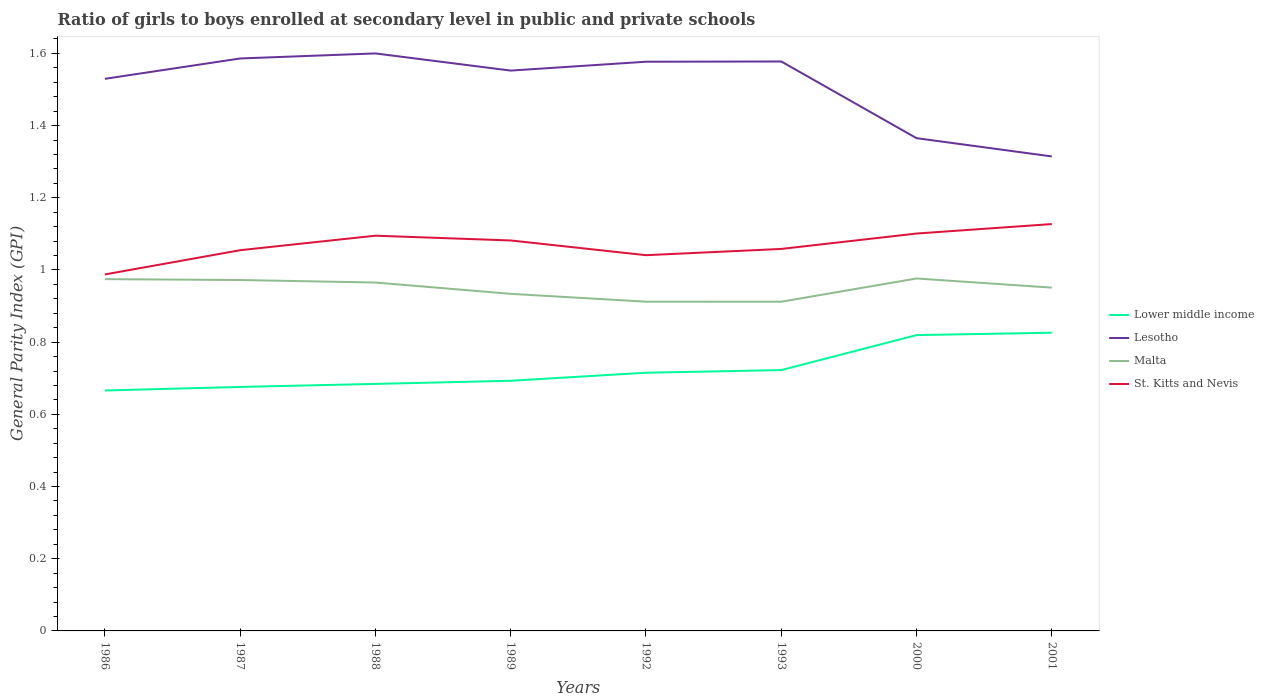Does the line corresponding to St. Kitts and Nevis intersect with the line corresponding to Lower middle income?
Give a very brief answer. No. Is the number of lines equal to the number of legend labels?
Provide a succinct answer. Yes. Across all years, what is the maximum general parity index in Lower middle income?
Your response must be concise. 0.67. In which year was the general parity index in St. Kitts and Nevis maximum?
Make the answer very short. 1986. What is the total general parity index in St. Kitts and Nevis in the graph?
Your response must be concise. -0.14. What is the difference between the highest and the second highest general parity index in Malta?
Keep it short and to the point. 0.06. Is the general parity index in Lesotho strictly greater than the general parity index in Lower middle income over the years?
Your answer should be compact. No. How many years are there in the graph?
Your answer should be very brief. 8. What is the difference between two consecutive major ticks on the Y-axis?
Offer a terse response. 0.2. Are the values on the major ticks of Y-axis written in scientific E-notation?
Offer a terse response. No. Where does the legend appear in the graph?
Offer a very short reply. Center right. What is the title of the graph?
Give a very brief answer. Ratio of girls to boys enrolled at secondary level in public and private schools. What is the label or title of the X-axis?
Your answer should be very brief. Years. What is the label or title of the Y-axis?
Give a very brief answer. General Parity Index (GPI). What is the General Parity Index (GPI) in Lower middle income in 1986?
Make the answer very short. 0.67. What is the General Parity Index (GPI) in Lesotho in 1986?
Provide a short and direct response. 1.53. What is the General Parity Index (GPI) in Malta in 1986?
Your response must be concise. 0.97. What is the General Parity Index (GPI) of St. Kitts and Nevis in 1986?
Ensure brevity in your answer.  0.99. What is the General Parity Index (GPI) of Lower middle income in 1987?
Your answer should be compact. 0.68. What is the General Parity Index (GPI) in Lesotho in 1987?
Provide a succinct answer. 1.59. What is the General Parity Index (GPI) of Malta in 1987?
Ensure brevity in your answer.  0.97. What is the General Parity Index (GPI) in St. Kitts and Nevis in 1987?
Your answer should be very brief. 1.05. What is the General Parity Index (GPI) of Lower middle income in 1988?
Your answer should be compact. 0.68. What is the General Parity Index (GPI) of Lesotho in 1988?
Keep it short and to the point. 1.6. What is the General Parity Index (GPI) of Malta in 1988?
Give a very brief answer. 0.97. What is the General Parity Index (GPI) in St. Kitts and Nevis in 1988?
Make the answer very short. 1.09. What is the General Parity Index (GPI) in Lower middle income in 1989?
Make the answer very short. 0.69. What is the General Parity Index (GPI) in Lesotho in 1989?
Ensure brevity in your answer.  1.55. What is the General Parity Index (GPI) of Malta in 1989?
Your answer should be compact. 0.93. What is the General Parity Index (GPI) in St. Kitts and Nevis in 1989?
Ensure brevity in your answer.  1.08. What is the General Parity Index (GPI) in Lower middle income in 1992?
Provide a short and direct response. 0.72. What is the General Parity Index (GPI) of Lesotho in 1992?
Give a very brief answer. 1.58. What is the General Parity Index (GPI) of Malta in 1992?
Provide a short and direct response. 0.91. What is the General Parity Index (GPI) in St. Kitts and Nevis in 1992?
Your response must be concise. 1.04. What is the General Parity Index (GPI) in Lower middle income in 1993?
Offer a terse response. 0.72. What is the General Parity Index (GPI) of Lesotho in 1993?
Make the answer very short. 1.58. What is the General Parity Index (GPI) of Malta in 1993?
Your answer should be very brief. 0.91. What is the General Parity Index (GPI) of St. Kitts and Nevis in 1993?
Ensure brevity in your answer.  1.06. What is the General Parity Index (GPI) in Lower middle income in 2000?
Your answer should be very brief. 0.82. What is the General Parity Index (GPI) in Lesotho in 2000?
Provide a short and direct response. 1.37. What is the General Parity Index (GPI) in Malta in 2000?
Your response must be concise. 0.98. What is the General Parity Index (GPI) in St. Kitts and Nevis in 2000?
Keep it short and to the point. 1.1. What is the General Parity Index (GPI) in Lower middle income in 2001?
Keep it short and to the point. 0.83. What is the General Parity Index (GPI) of Lesotho in 2001?
Provide a short and direct response. 1.31. What is the General Parity Index (GPI) of Malta in 2001?
Provide a short and direct response. 0.95. What is the General Parity Index (GPI) in St. Kitts and Nevis in 2001?
Your answer should be compact. 1.13. Across all years, what is the maximum General Parity Index (GPI) in Lower middle income?
Ensure brevity in your answer.  0.83. Across all years, what is the maximum General Parity Index (GPI) of Lesotho?
Your answer should be very brief. 1.6. Across all years, what is the maximum General Parity Index (GPI) in Malta?
Ensure brevity in your answer.  0.98. Across all years, what is the maximum General Parity Index (GPI) of St. Kitts and Nevis?
Keep it short and to the point. 1.13. Across all years, what is the minimum General Parity Index (GPI) of Lower middle income?
Your answer should be very brief. 0.67. Across all years, what is the minimum General Parity Index (GPI) of Lesotho?
Offer a very short reply. 1.31. Across all years, what is the minimum General Parity Index (GPI) of Malta?
Offer a very short reply. 0.91. Across all years, what is the minimum General Parity Index (GPI) in St. Kitts and Nevis?
Your answer should be compact. 0.99. What is the total General Parity Index (GPI) in Lower middle income in the graph?
Keep it short and to the point. 5.8. What is the total General Parity Index (GPI) in Lesotho in the graph?
Your answer should be very brief. 12.1. What is the total General Parity Index (GPI) in Malta in the graph?
Your answer should be very brief. 7.6. What is the total General Parity Index (GPI) in St. Kitts and Nevis in the graph?
Offer a terse response. 8.55. What is the difference between the General Parity Index (GPI) in Lower middle income in 1986 and that in 1987?
Make the answer very short. -0.01. What is the difference between the General Parity Index (GPI) in Lesotho in 1986 and that in 1987?
Keep it short and to the point. -0.06. What is the difference between the General Parity Index (GPI) in Malta in 1986 and that in 1987?
Provide a succinct answer. 0. What is the difference between the General Parity Index (GPI) of St. Kitts and Nevis in 1986 and that in 1987?
Ensure brevity in your answer.  -0.07. What is the difference between the General Parity Index (GPI) of Lower middle income in 1986 and that in 1988?
Your answer should be very brief. -0.02. What is the difference between the General Parity Index (GPI) of Lesotho in 1986 and that in 1988?
Keep it short and to the point. -0.07. What is the difference between the General Parity Index (GPI) of Malta in 1986 and that in 1988?
Keep it short and to the point. 0.01. What is the difference between the General Parity Index (GPI) of St. Kitts and Nevis in 1986 and that in 1988?
Provide a short and direct response. -0.11. What is the difference between the General Parity Index (GPI) in Lower middle income in 1986 and that in 1989?
Give a very brief answer. -0.03. What is the difference between the General Parity Index (GPI) of Lesotho in 1986 and that in 1989?
Your answer should be very brief. -0.02. What is the difference between the General Parity Index (GPI) in Malta in 1986 and that in 1989?
Your answer should be very brief. 0.04. What is the difference between the General Parity Index (GPI) in St. Kitts and Nevis in 1986 and that in 1989?
Provide a succinct answer. -0.09. What is the difference between the General Parity Index (GPI) in Lower middle income in 1986 and that in 1992?
Your response must be concise. -0.05. What is the difference between the General Parity Index (GPI) in Lesotho in 1986 and that in 1992?
Ensure brevity in your answer.  -0.05. What is the difference between the General Parity Index (GPI) of Malta in 1986 and that in 1992?
Your answer should be compact. 0.06. What is the difference between the General Parity Index (GPI) of St. Kitts and Nevis in 1986 and that in 1992?
Keep it short and to the point. -0.05. What is the difference between the General Parity Index (GPI) in Lower middle income in 1986 and that in 1993?
Provide a succinct answer. -0.06. What is the difference between the General Parity Index (GPI) in Lesotho in 1986 and that in 1993?
Offer a very short reply. -0.05. What is the difference between the General Parity Index (GPI) in Malta in 1986 and that in 1993?
Offer a terse response. 0.06. What is the difference between the General Parity Index (GPI) in St. Kitts and Nevis in 1986 and that in 1993?
Give a very brief answer. -0.07. What is the difference between the General Parity Index (GPI) in Lower middle income in 1986 and that in 2000?
Make the answer very short. -0.15. What is the difference between the General Parity Index (GPI) in Lesotho in 1986 and that in 2000?
Make the answer very short. 0.16. What is the difference between the General Parity Index (GPI) of Malta in 1986 and that in 2000?
Provide a succinct answer. -0. What is the difference between the General Parity Index (GPI) in St. Kitts and Nevis in 1986 and that in 2000?
Provide a short and direct response. -0.11. What is the difference between the General Parity Index (GPI) in Lower middle income in 1986 and that in 2001?
Provide a short and direct response. -0.16. What is the difference between the General Parity Index (GPI) in Lesotho in 1986 and that in 2001?
Your answer should be very brief. 0.21. What is the difference between the General Parity Index (GPI) in Malta in 1986 and that in 2001?
Your answer should be compact. 0.02. What is the difference between the General Parity Index (GPI) of St. Kitts and Nevis in 1986 and that in 2001?
Provide a short and direct response. -0.14. What is the difference between the General Parity Index (GPI) in Lower middle income in 1987 and that in 1988?
Offer a terse response. -0.01. What is the difference between the General Parity Index (GPI) of Lesotho in 1987 and that in 1988?
Your answer should be very brief. -0.01. What is the difference between the General Parity Index (GPI) of Malta in 1987 and that in 1988?
Your answer should be compact. 0.01. What is the difference between the General Parity Index (GPI) in St. Kitts and Nevis in 1987 and that in 1988?
Your answer should be very brief. -0.04. What is the difference between the General Parity Index (GPI) in Lower middle income in 1987 and that in 1989?
Keep it short and to the point. -0.02. What is the difference between the General Parity Index (GPI) in Lesotho in 1987 and that in 1989?
Give a very brief answer. 0.03. What is the difference between the General Parity Index (GPI) in Malta in 1987 and that in 1989?
Offer a very short reply. 0.04. What is the difference between the General Parity Index (GPI) of St. Kitts and Nevis in 1987 and that in 1989?
Offer a terse response. -0.03. What is the difference between the General Parity Index (GPI) of Lower middle income in 1987 and that in 1992?
Ensure brevity in your answer.  -0.04. What is the difference between the General Parity Index (GPI) in Lesotho in 1987 and that in 1992?
Offer a very short reply. 0.01. What is the difference between the General Parity Index (GPI) in Malta in 1987 and that in 1992?
Offer a very short reply. 0.06. What is the difference between the General Parity Index (GPI) in St. Kitts and Nevis in 1987 and that in 1992?
Your answer should be compact. 0.01. What is the difference between the General Parity Index (GPI) in Lower middle income in 1987 and that in 1993?
Your answer should be very brief. -0.05. What is the difference between the General Parity Index (GPI) of Lesotho in 1987 and that in 1993?
Give a very brief answer. 0.01. What is the difference between the General Parity Index (GPI) of Malta in 1987 and that in 1993?
Give a very brief answer. 0.06. What is the difference between the General Parity Index (GPI) of St. Kitts and Nevis in 1987 and that in 1993?
Give a very brief answer. -0. What is the difference between the General Parity Index (GPI) of Lower middle income in 1987 and that in 2000?
Keep it short and to the point. -0.14. What is the difference between the General Parity Index (GPI) in Lesotho in 1987 and that in 2000?
Make the answer very short. 0.22. What is the difference between the General Parity Index (GPI) of Malta in 1987 and that in 2000?
Your answer should be compact. -0. What is the difference between the General Parity Index (GPI) of St. Kitts and Nevis in 1987 and that in 2000?
Provide a succinct answer. -0.05. What is the difference between the General Parity Index (GPI) in Lower middle income in 1987 and that in 2001?
Make the answer very short. -0.15. What is the difference between the General Parity Index (GPI) of Lesotho in 1987 and that in 2001?
Provide a short and direct response. 0.27. What is the difference between the General Parity Index (GPI) in Malta in 1987 and that in 2001?
Offer a terse response. 0.02. What is the difference between the General Parity Index (GPI) in St. Kitts and Nevis in 1987 and that in 2001?
Ensure brevity in your answer.  -0.07. What is the difference between the General Parity Index (GPI) of Lower middle income in 1988 and that in 1989?
Ensure brevity in your answer.  -0.01. What is the difference between the General Parity Index (GPI) in Lesotho in 1988 and that in 1989?
Ensure brevity in your answer.  0.05. What is the difference between the General Parity Index (GPI) of Malta in 1988 and that in 1989?
Keep it short and to the point. 0.03. What is the difference between the General Parity Index (GPI) in St. Kitts and Nevis in 1988 and that in 1989?
Offer a terse response. 0.01. What is the difference between the General Parity Index (GPI) of Lower middle income in 1988 and that in 1992?
Ensure brevity in your answer.  -0.03. What is the difference between the General Parity Index (GPI) in Lesotho in 1988 and that in 1992?
Give a very brief answer. 0.02. What is the difference between the General Parity Index (GPI) of Malta in 1988 and that in 1992?
Keep it short and to the point. 0.05. What is the difference between the General Parity Index (GPI) of St. Kitts and Nevis in 1988 and that in 1992?
Your answer should be compact. 0.05. What is the difference between the General Parity Index (GPI) in Lower middle income in 1988 and that in 1993?
Your answer should be very brief. -0.04. What is the difference between the General Parity Index (GPI) in Lesotho in 1988 and that in 1993?
Make the answer very short. 0.02. What is the difference between the General Parity Index (GPI) in Malta in 1988 and that in 1993?
Offer a terse response. 0.05. What is the difference between the General Parity Index (GPI) in St. Kitts and Nevis in 1988 and that in 1993?
Your answer should be very brief. 0.04. What is the difference between the General Parity Index (GPI) in Lower middle income in 1988 and that in 2000?
Offer a terse response. -0.14. What is the difference between the General Parity Index (GPI) in Lesotho in 1988 and that in 2000?
Keep it short and to the point. 0.23. What is the difference between the General Parity Index (GPI) of Malta in 1988 and that in 2000?
Provide a succinct answer. -0.01. What is the difference between the General Parity Index (GPI) in St. Kitts and Nevis in 1988 and that in 2000?
Your answer should be very brief. -0.01. What is the difference between the General Parity Index (GPI) in Lower middle income in 1988 and that in 2001?
Ensure brevity in your answer.  -0.14. What is the difference between the General Parity Index (GPI) in Lesotho in 1988 and that in 2001?
Provide a short and direct response. 0.29. What is the difference between the General Parity Index (GPI) of Malta in 1988 and that in 2001?
Ensure brevity in your answer.  0.01. What is the difference between the General Parity Index (GPI) of St. Kitts and Nevis in 1988 and that in 2001?
Make the answer very short. -0.03. What is the difference between the General Parity Index (GPI) of Lower middle income in 1989 and that in 1992?
Your answer should be very brief. -0.02. What is the difference between the General Parity Index (GPI) in Lesotho in 1989 and that in 1992?
Provide a succinct answer. -0.02. What is the difference between the General Parity Index (GPI) in Malta in 1989 and that in 1992?
Ensure brevity in your answer.  0.02. What is the difference between the General Parity Index (GPI) in St. Kitts and Nevis in 1989 and that in 1992?
Offer a very short reply. 0.04. What is the difference between the General Parity Index (GPI) of Lower middle income in 1989 and that in 1993?
Ensure brevity in your answer.  -0.03. What is the difference between the General Parity Index (GPI) of Lesotho in 1989 and that in 1993?
Give a very brief answer. -0.03. What is the difference between the General Parity Index (GPI) in Malta in 1989 and that in 1993?
Make the answer very short. 0.02. What is the difference between the General Parity Index (GPI) of St. Kitts and Nevis in 1989 and that in 1993?
Make the answer very short. 0.02. What is the difference between the General Parity Index (GPI) in Lower middle income in 1989 and that in 2000?
Offer a very short reply. -0.13. What is the difference between the General Parity Index (GPI) of Lesotho in 1989 and that in 2000?
Give a very brief answer. 0.19. What is the difference between the General Parity Index (GPI) of Malta in 1989 and that in 2000?
Ensure brevity in your answer.  -0.04. What is the difference between the General Parity Index (GPI) in St. Kitts and Nevis in 1989 and that in 2000?
Your answer should be very brief. -0.02. What is the difference between the General Parity Index (GPI) in Lower middle income in 1989 and that in 2001?
Your answer should be very brief. -0.13. What is the difference between the General Parity Index (GPI) of Lesotho in 1989 and that in 2001?
Give a very brief answer. 0.24. What is the difference between the General Parity Index (GPI) in Malta in 1989 and that in 2001?
Make the answer very short. -0.02. What is the difference between the General Parity Index (GPI) in St. Kitts and Nevis in 1989 and that in 2001?
Keep it short and to the point. -0.05. What is the difference between the General Parity Index (GPI) of Lower middle income in 1992 and that in 1993?
Your response must be concise. -0.01. What is the difference between the General Parity Index (GPI) of Lesotho in 1992 and that in 1993?
Provide a short and direct response. -0. What is the difference between the General Parity Index (GPI) of St. Kitts and Nevis in 1992 and that in 1993?
Provide a succinct answer. -0.02. What is the difference between the General Parity Index (GPI) in Lower middle income in 1992 and that in 2000?
Your answer should be compact. -0.1. What is the difference between the General Parity Index (GPI) of Lesotho in 1992 and that in 2000?
Keep it short and to the point. 0.21. What is the difference between the General Parity Index (GPI) in Malta in 1992 and that in 2000?
Provide a short and direct response. -0.06. What is the difference between the General Parity Index (GPI) of St. Kitts and Nevis in 1992 and that in 2000?
Offer a very short reply. -0.06. What is the difference between the General Parity Index (GPI) in Lower middle income in 1992 and that in 2001?
Provide a short and direct response. -0.11. What is the difference between the General Parity Index (GPI) in Lesotho in 1992 and that in 2001?
Your response must be concise. 0.26. What is the difference between the General Parity Index (GPI) in Malta in 1992 and that in 2001?
Ensure brevity in your answer.  -0.04. What is the difference between the General Parity Index (GPI) of St. Kitts and Nevis in 1992 and that in 2001?
Provide a short and direct response. -0.09. What is the difference between the General Parity Index (GPI) in Lower middle income in 1993 and that in 2000?
Offer a terse response. -0.1. What is the difference between the General Parity Index (GPI) in Lesotho in 1993 and that in 2000?
Make the answer very short. 0.21. What is the difference between the General Parity Index (GPI) of Malta in 1993 and that in 2000?
Offer a very short reply. -0.06. What is the difference between the General Parity Index (GPI) in St. Kitts and Nevis in 1993 and that in 2000?
Give a very brief answer. -0.04. What is the difference between the General Parity Index (GPI) in Lower middle income in 1993 and that in 2001?
Provide a short and direct response. -0.1. What is the difference between the General Parity Index (GPI) in Lesotho in 1993 and that in 2001?
Your answer should be very brief. 0.26. What is the difference between the General Parity Index (GPI) in Malta in 1993 and that in 2001?
Give a very brief answer. -0.04. What is the difference between the General Parity Index (GPI) of St. Kitts and Nevis in 1993 and that in 2001?
Offer a very short reply. -0.07. What is the difference between the General Parity Index (GPI) of Lower middle income in 2000 and that in 2001?
Provide a short and direct response. -0.01. What is the difference between the General Parity Index (GPI) in Lesotho in 2000 and that in 2001?
Provide a succinct answer. 0.05. What is the difference between the General Parity Index (GPI) in Malta in 2000 and that in 2001?
Your answer should be compact. 0.03. What is the difference between the General Parity Index (GPI) of St. Kitts and Nevis in 2000 and that in 2001?
Make the answer very short. -0.03. What is the difference between the General Parity Index (GPI) in Lower middle income in 1986 and the General Parity Index (GPI) in Lesotho in 1987?
Make the answer very short. -0.92. What is the difference between the General Parity Index (GPI) of Lower middle income in 1986 and the General Parity Index (GPI) of Malta in 1987?
Keep it short and to the point. -0.31. What is the difference between the General Parity Index (GPI) of Lower middle income in 1986 and the General Parity Index (GPI) of St. Kitts and Nevis in 1987?
Make the answer very short. -0.39. What is the difference between the General Parity Index (GPI) in Lesotho in 1986 and the General Parity Index (GPI) in Malta in 1987?
Ensure brevity in your answer.  0.56. What is the difference between the General Parity Index (GPI) in Lesotho in 1986 and the General Parity Index (GPI) in St. Kitts and Nevis in 1987?
Offer a terse response. 0.47. What is the difference between the General Parity Index (GPI) in Malta in 1986 and the General Parity Index (GPI) in St. Kitts and Nevis in 1987?
Your answer should be compact. -0.08. What is the difference between the General Parity Index (GPI) in Lower middle income in 1986 and the General Parity Index (GPI) in Lesotho in 1988?
Offer a very short reply. -0.93. What is the difference between the General Parity Index (GPI) of Lower middle income in 1986 and the General Parity Index (GPI) of Malta in 1988?
Offer a terse response. -0.3. What is the difference between the General Parity Index (GPI) in Lower middle income in 1986 and the General Parity Index (GPI) in St. Kitts and Nevis in 1988?
Your answer should be very brief. -0.43. What is the difference between the General Parity Index (GPI) in Lesotho in 1986 and the General Parity Index (GPI) in Malta in 1988?
Offer a terse response. 0.56. What is the difference between the General Parity Index (GPI) of Lesotho in 1986 and the General Parity Index (GPI) of St. Kitts and Nevis in 1988?
Your answer should be very brief. 0.43. What is the difference between the General Parity Index (GPI) in Malta in 1986 and the General Parity Index (GPI) in St. Kitts and Nevis in 1988?
Keep it short and to the point. -0.12. What is the difference between the General Parity Index (GPI) of Lower middle income in 1986 and the General Parity Index (GPI) of Lesotho in 1989?
Provide a succinct answer. -0.89. What is the difference between the General Parity Index (GPI) of Lower middle income in 1986 and the General Parity Index (GPI) of Malta in 1989?
Provide a short and direct response. -0.27. What is the difference between the General Parity Index (GPI) of Lower middle income in 1986 and the General Parity Index (GPI) of St. Kitts and Nevis in 1989?
Give a very brief answer. -0.42. What is the difference between the General Parity Index (GPI) of Lesotho in 1986 and the General Parity Index (GPI) of Malta in 1989?
Provide a succinct answer. 0.6. What is the difference between the General Parity Index (GPI) of Lesotho in 1986 and the General Parity Index (GPI) of St. Kitts and Nevis in 1989?
Provide a succinct answer. 0.45. What is the difference between the General Parity Index (GPI) of Malta in 1986 and the General Parity Index (GPI) of St. Kitts and Nevis in 1989?
Give a very brief answer. -0.11. What is the difference between the General Parity Index (GPI) in Lower middle income in 1986 and the General Parity Index (GPI) in Lesotho in 1992?
Your answer should be compact. -0.91. What is the difference between the General Parity Index (GPI) of Lower middle income in 1986 and the General Parity Index (GPI) of Malta in 1992?
Provide a short and direct response. -0.25. What is the difference between the General Parity Index (GPI) of Lower middle income in 1986 and the General Parity Index (GPI) of St. Kitts and Nevis in 1992?
Keep it short and to the point. -0.37. What is the difference between the General Parity Index (GPI) in Lesotho in 1986 and the General Parity Index (GPI) in Malta in 1992?
Your answer should be compact. 0.62. What is the difference between the General Parity Index (GPI) of Lesotho in 1986 and the General Parity Index (GPI) of St. Kitts and Nevis in 1992?
Give a very brief answer. 0.49. What is the difference between the General Parity Index (GPI) in Malta in 1986 and the General Parity Index (GPI) in St. Kitts and Nevis in 1992?
Give a very brief answer. -0.07. What is the difference between the General Parity Index (GPI) in Lower middle income in 1986 and the General Parity Index (GPI) in Lesotho in 1993?
Your answer should be compact. -0.91. What is the difference between the General Parity Index (GPI) in Lower middle income in 1986 and the General Parity Index (GPI) in Malta in 1993?
Offer a terse response. -0.25. What is the difference between the General Parity Index (GPI) of Lower middle income in 1986 and the General Parity Index (GPI) of St. Kitts and Nevis in 1993?
Offer a terse response. -0.39. What is the difference between the General Parity Index (GPI) of Lesotho in 1986 and the General Parity Index (GPI) of Malta in 1993?
Give a very brief answer. 0.62. What is the difference between the General Parity Index (GPI) of Lesotho in 1986 and the General Parity Index (GPI) of St. Kitts and Nevis in 1993?
Your answer should be very brief. 0.47. What is the difference between the General Parity Index (GPI) of Malta in 1986 and the General Parity Index (GPI) of St. Kitts and Nevis in 1993?
Make the answer very short. -0.08. What is the difference between the General Parity Index (GPI) of Lower middle income in 1986 and the General Parity Index (GPI) of Lesotho in 2000?
Your answer should be compact. -0.7. What is the difference between the General Parity Index (GPI) of Lower middle income in 1986 and the General Parity Index (GPI) of Malta in 2000?
Give a very brief answer. -0.31. What is the difference between the General Parity Index (GPI) in Lower middle income in 1986 and the General Parity Index (GPI) in St. Kitts and Nevis in 2000?
Ensure brevity in your answer.  -0.43. What is the difference between the General Parity Index (GPI) of Lesotho in 1986 and the General Parity Index (GPI) of Malta in 2000?
Your answer should be very brief. 0.55. What is the difference between the General Parity Index (GPI) of Lesotho in 1986 and the General Parity Index (GPI) of St. Kitts and Nevis in 2000?
Keep it short and to the point. 0.43. What is the difference between the General Parity Index (GPI) in Malta in 1986 and the General Parity Index (GPI) in St. Kitts and Nevis in 2000?
Provide a short and direct response. -0.13. What is the difference between the General Parity Index (GPI) of Lower middle income in 1986 and the General Parity Index (GPI) of Lesotho in 2001?
Offer a very short reply. -0.65. What is the difference between the General Parity Index (GPI) in Lower middle income in 1986 and the General Parity Index (GPI) in Malta in 2001?
Ensure brevity in your answer.  -0.28. What is the difference between the General Parity Index (GPI) in Lower middle income in 1986 and the General Parity Index (GPI) in St. Kitts and Nevis in 2001?
Provide a short and direct response. -0.46. What is the difference between the General Parity Index (GPI) of Lesotho in 1986 and the General Parity Index (GPI) of Malta in 2001?
Your answer should be very brief. 0.58. What is the difference between the General Parity Index (GPI) in Lesotho in 1986 and the General Parity Index (GPI) in St. Kitts and Nevis in 2001?
Make the answer very short. 0.4. What is the difference between the General Parity Index (GPI) in Malta in 1986 and the General Parity Index (GPI) in St. Kitts and Nevis in 2001?
Your response must be concise. -0.15. What is the difference between the General Parity Index (GPI) in Lower middle income in 1987 and the General Parity Index (GPI) in Lesotho in 1988?
Give a very brief answer. -0.92. What is the difference between the General Parity Index (GPI) in Lower middle income in 1987 and the General Parity Index (GPI) in Malta in 1988?
Your answer should be compact. -0.29. What is the difference between the General Parity Index (GPI) of Lower middle income in 1987 and the General Parity Index (GPI) of St. Kitts and Nevis in 1988?
Ensure brevity in your answer.  -0.42. What is the difference between the General Parity Index (GPI) of Lesotho in 1987 and the General Parity Index (GPI) of Malta in 1988?
Your answer should be compact. 0.62. What is the difference between the General Parity Index (GPI) in Lesotho in 1987 and the General Parity Index (GPI) in St. Kitts and Nevis in 1988?
Make the answer very short. 0.49. What is the difference between the General Parity Index (GPI) of Malta in 1987 and the General Parity Index (GPI) of St. Kitts and Nevis in 1988?
Provide a succinct answer. -0.12. What is the difference between the General Parity Index (GPI) of Lower middle income in 1987 and the General Parity Index (GPI) of Lesotho in 1989?
Give a very brief answer. -0.88. What is the difference between the General Parity Index (GPI) in Lower middle income in 1987 and the General Parity Index (GPI) in Malta in 1989?
Your answer should be very brief. -0.26. What is the difference between the General Parity Index (GPI) of Lower middle income in 1987 and the General Parity Index (GPI) of St. Kitts and Nevis in 1989?
Ensure brevity in your answer.  -0.41. What is the difference between the General Parity Index (GPI) of Lesotho in 1987 and the General Parity Index (GPI) of Malta in 1989?
Keep it short and to the point. 0.65. What is the difference between the General Parity Index (GPI) of Lesotho in 1987 and the General Parity Index (GPI) of St. Kitts and Nevis in 1989?
Your response must be concise. 0.5. What is the difference between the General Parity Index (GPI) of Malta in 1987 and the General Parity Index (GPI) of St. Kitts and Nevis in 1989?
Make the answer very short. -0.11. What is the difference between the General Parity Index (GPI) in Lower middle income in 1987 and the General Parity Index (GPI) in Lesotho in 1992?
Ensure brevity in your answer.  -0.9. What is the difference between the General Parity Index (GPI) in Lower middle income in 1987 and the General Parity Index (GPI) in Malta in 1992?
Make the answer very short. -0.24. What is the difference between the General Parity Index (GPI) in Lower middle income in 1987 and the General Parity Index (GPI) in St. Kitts and Nevis in 1992?
Keep it short and to the point. -0.36. What is the difference between the General Parity Index (GPI) in Lesotho in 1987 and the General Parity Index (GPI) in Malta in 1992?
Make the answer very short. 0.67. What is the difference between the General Parity Index (GPI) of Lesotho in 1987 and the General Parity Index (GPI) of St. Kitts and Nevis in 1992?
Your answer should be very brief. 0.55. What is the difference between the General Parity Index (GPI) in Malta in 1987 and the General Parity Index (GPI) in St. Kitts and Nevis in 1992?
Your response must be concise. -0.07. What is the difference between the General Parity Index (GPI) in Lower middle income in 1987 and the General Parity Index (GPI) in Lesotho in 1993?
Keep it short and to the point. -0.9. What is the difference between the General Parity Index (GPI) in Lower middle income in 1987 and the General Parity Index (GPI) in Malta in 1993?
Provide a succinct answer. -0.24. What is the difference between the General Parity Index (GPI) in Lower middle income in 1987 and the General Parity Index (GPI) in St. Kitts and Nevis in 1993?
Offer a very short reply. -0.38. What is the difference between the General Parity Index (GPI) of Lesotho in 1987 and the General Parity Index (GPI) of Malta in 1993?
Keep it short and to the point. 0.67. What is the difference between the General Parity Index (GPI) in Lesotho in 1987 and the General Parity Index (GPI) in St. Kitts and Nevis in 1993?
Your answer should be very brief. 0.53. What is the difference between the General Parity Index (GPI) of Malta in 1987 and the General Parity Index (GPI) of St. Kitts and Nevis in 1993?
Your answer should be very brief. -0.09. What is the difference between the General Parity Index (GPI) in Lower middle income in 1987 and the General Parity Index (GPI) in Lesotho in 2000?
Offer a very short reply. -0.69. What is the difference between the General Parity Index (GPI) of Lower middle income in 1987 and the General Parity Index (GPI) of Malta in 2000?
Your response must be concise. -0.3. What is the difference between the General Parity Index (GPI) of Lower middle income in 1987 and the General Parity Index (GPI) of St. Kitts and Nevis in 2000?
Ensure brevity in your answer.  -0.42. What is the difference between the General Parity Index (GPI) of Lesotho in 1987 and the General Parity Index (GPI) of Malta in 2000?
Make the answer very short. 0.61. What is the difference between the General Parity Index (GPI) in Lesotho in 1987 and the General Parity Index (GPI) in St. Kitts and Nevis in 2000?
Offer a very short reply. 0.48. What is the difference between the General Parity Index (GPI) in Malta in 1987 and the General Parity Index (GPI) in St. Kitts and Nevis in 2000?
Keep it short and to the point. -0.13. What is the difference between the General Parity Index (GPI) of Lower middle income in 1987 and the General Parity Index (GPI) of Lesotho in 2001?
Your answer should be compact. -0.64. What is the difference between the General Parity Index (GPI) in Lower middle income in 1987 and the General Parity Index (GPI) in Malta in 2001?
Offer a very short reply. -0.28. What is the difference between the General Parity Index (GPI) of Lower middle income in 1987 and the General Parity Index (GPI) of St. Kitts and Nevis in 2001?
Make the answer very short. -0.45. What is the difference between the General Parity Index (GPI) in Lesotho in 1987 and the General Parity Index (GPI) in Malta in 2001?
Offer a terse response. 0.63. What is the difference between the General Parity Index (GPI) in Lesotho in 1987 and the General Parity Index (GPI) in St. Kitts and Nevis in 2001?
Provide a succinct answer. 0.46. What is the difference between the General Parity Index (GPI) of Malta in 1987 and the General Parity Index (GPI) of St. Kitts and Nevis in 2001?
Ensure brevity in your answer.  -0.15. What is the difference between the General Parity Index (GPI) of Lower middle income in 1988 and the General Parity Index (GPI) of Lesotho in 1989?
Your response must be concise. -0.87. What is the difference between the General Parity Index (GPI) of Lower middle income in 1988 and the General Parity Index (GPI) of Malta in 1989?
Offer a very short reply. -0.25. What is the difference between the General Parity Index (GPI) in Lower middle income in 1988 and the General Parity Index (GPI) in St. Kitts and Nevis in 1989?
Provide a succinct answer. -0.4. What is the difference between the General Parity Index (GPI) in Lesotho in 1988 and the General Parity Index (GPI) in Malta in 1989?
Your answer should be very brief. 0.67. What is the difference between the General Parity Index (GPI) of Lesotho in 1988 and the General Parity Index (GPI) of St. Kitts and Nevis in 1989?
Your response must be concise. 0.52. What is the difference between the General Parity Index (GPI) of Malta in 1988 and the General Parity Index (GPI) of St. Kitts and Nevis in 1989?
Your response must be concise. -0.12. What is the difference between the General Parity Index (GPI) of Lower middle income in 1988 and the General Parity Index (GPI) of Lesotho in 1992?
Your answer should be compact. -0.89. What is the difference between the General Parity Index (GPI) in Lower middle income in 1988 and the General Parity Index (GPI) in Malta in 1992?
Make the answer very short. -0.23. What is the difference between the General Parity Index (GPI) in Lower middle income in 1988 and the General Parity Index (GPI) in St. Kitts and Nevis in 1992?
Offer a very short reply. -0.36. What is the difference between the General Parity Index (GPI) in Lesotho in 1988 and the General Parity Index (GPI) in Malta in 1992?
Ensure brevity in your answer.  0.69. What is the difference between the General Parity Index (GPI) in Lesotho in 1988 and the General Parity Index (GPI) in St. Kitts and Nevis in 1992?
Offer a very short reply. 0.56. What is the difference between the General Parity Index (GPI) in Malta in 1988 and the General Parity Index (GPI) in St. Kitts and Nevis in 1992?
Your answer should be compact. -0.08. What is the difference between the General Parity Index (GPI) of Lower middle income in 1988 and the General Parity Index (GPI) of Lesotho in 1993?
Offer a terse response. -0.89. What is the difference between the General Parity Index (GPI) in Lower middle income in 1988 and the General Parity Index (GPI) in Malta in 1993?
Your response must be concise. -0.23. What is the difference between the General Parity Index (GPI) of Lower middle income in 1988 and the General Parity Index (GPI) of St. Kitts and Nevis in 1993?
Offer a terse response. -0.37. What is the difference between the General Parity Index (GPI) of Lesotho in 1988 and the General Parity Index (GPI) of Malta in 1993?
Ensure brevity in your answer.  0.69. What is the difference between the General Parity Index (GPI) in Lesotho in 1988 and the General Parity Index (GPI) in St. Kitts and Nevis in 1993?
Your answer should be compact. 0.54. What is the difference between the General Parity Index (GPI) of Malta in 1988 and the General Parity Index (GPI) of St. Kitts and Nevis in 1993?
Make the answer very short. -0.09. What is the difference between the General Parity Index (GPI) in Lower middle income in 1988 and the General Parity Index (GPI) in Lesotho in 2000?
Make the answer very short. -0.68. What is the difference between the General Parity Index (GPI) of Lower middle income in 1988 and the General Parity Index (GPI) of Malta in 2000?
Offer a terse response. -0.29. What is the difference between the General Parity Index (GPI) in Lower middle income in 1988 and the General Parity Index (GPI) in St. Kitts and Nevis in 2000?
Offer a very short reply. -0.42. What is the difference between the General Parity Index (GPI) of Lesotho in 1988 and the General Parity Index (GPI) of Malta in 2000?
Offer a terse response. 0.62. What is the difference between the General Parity Index (GPI) of Lesotho in 1988 and the General Parity Index (GPI) of St. Kitts and Nevis in 2000?
Offer a very short reply. 0.5. What is the difference between the General Parity Index (GPI) in Malta in 1988 and the General Parity Index (GPI) in St. Kitts and Nevis in 2000?
Provide a succinct answer. -0.14. What is the difference between the General Parity Index (GPI) in Lower middle income in 1988 and the General Parity Index (GPI) in Lesotho in 2001?
Your answer should be compact. -0.63. What is the difference between the General Parity Index (GPI) of Lower middle income in 1988 and the General Parity Index (GPI) of Malta in 2001?
Provide a short and direct response. -0.27. What is the difference between the General Parity Index (GPI) of Lower middle income in 1988 and the General Parity Index (GPI) of St. Kitts and Nevis in 2001?
Offer a very short reply. -0.44. What is the difference between the General Parity Index (GPI) of Lesotho in 1988 and the General Parity Index (GPI) of Malta in 2001?
Give a very brief answer. 0.65. What is the difference between the General Parity Index (GPI) in Lesotho in 1988 and the General Parity Index (GPI) in St. Kitts and Nevis in 2001?
Ensure brevity in your answer.  0.47. What is the difference between the General Parity Index (GPI) in Malta in 1988 and the General Parity Index (GPI) in St. Kitts and Nevis in 2001?
Ensure brevity in your answer.  -0.16. What is the difference between the General Parity Index (GPI) in Lower middle income in 1989 and the General Parity Index (GPI) in Lesotho in 1992?
Offer a very short reply. -0.88. What is the difference between the General Parity Index (GPI) in Lower middle income in 1989 and the General Parity Index (GPI) in Malta in 1992?
Offer a terse response. -0.22. What is the difference between the General Parity Index (GPI) in Lower middle income in 1989 and the General Parity Index (GPI) in St. Kitts and Nevis in 1992?
Offer a terse response. -0.35. What is the difference between the General Parity Index (GPI) of Lesotho in 1989 and the General Parity Index (GPI) of Malta in 1992?
Provide a succinct answer. 0.64. What is the difference between the General Parity Index (GPI) in Lesotho in 1989 and the General Parity Index (GPI) in St. Kitts and Nevis in 1992?
Your answer should be compact. 0.51. What is the difference between the General Parity Index (GPI) of Malta in 1989 and the General Parity Index (GPI) of St. Kitts and Nevis in 1992?
Offer a very short reply. -0.11. What is the difference between the General Parity Index (GPI) of Lower middle income in 1989 and the General Parity Index (GPI) of Lesotho in 1993?
Give a very brief answer. -0.88. What is the difference between the General Parity Index (GPI) in Lower middle income in 1989 and the General Parity Index (GPI) in Malta in 1993?
Make the answer very short. -0.22. What is the difference between the General Parity Index (GPI) in Lower middle income in 1989 and the General Parity Index (GPI) in St. Kitts and Nevis in 1993?
Your answer should be compact. -0.37. What is the difference between the General Parity Index (GPI) in Lesotho in 1989 and the General Parity Index (GPI) in Malta in 1993?
Your answer should be compact. 0.64. What is the difference between the General Parity Index (GPI) in Lesotho in 1989 and the General Parity Index (GPI) in St. Kitts and Nevis in 1993?
Your response must be concise. 0.49. What is the difference between the General Parity Index (GPI) of Malta in 1989 and the General Parity Index (GPI) of St. Kitts and Nevis in 1993?
Your answer should be compact. -0.12. What is the difference between the General Parity Index (GPI) of Lower middle income in 1989 and the General Parity Index (GPI) of Lesotho in 2000?
Ensure brevity in your answer.  -0.67. What is the difference between the General Parity Index (GPI) in Lower middle income in 1989 and the General Parity Index (GPI) in Malta in 2000?
Give a very brief answer. -0.28. What is the difference between the General Parity Index (GPI) of Lower middle income in 1989 and the General Parity Index (GPI) of St. Kitts and Nevis in 2000?
Provide a short and direct response. -0.41. What is the difference between the General Parity Index (GPI) in Lesotho in 1989 and the General Parity Index (GPI) in Malta in 2000?
Your answer should be compact. 0.58. What is the difference between the General Parity Index (GPI) of Lesotho in 1989 and the General Parity Index (GPI) of St. Kitts and Nevis in 2000?
Provide a succinct answer. 0.45. What is the difference between the General Parity Index (GPI) in Malta in 1989 and the General Parity Index (GPI) in St. Kitts and Nevis in 2000?
Your response must be concise. -0.17. What is the difference between the General Parity Index (GPI) of Lower middle income in 1989 and the General Parity Index (GPI) of Lesotho in 2001?
Provide a short and direct response. -0.62. What is the difference between the General Parity Index (GPI) in Lower middle income in 1989 and the General Parity Index (GPI) in Malta in 2001?
Offer a terse response. -0.26. What is the difference between the General Parity Index (GPI) in Lower middle income in 1989 and the General Parity Index (GPI) in St. Kitts and Nevis in 2001?
Ensure brevity in your answer.  -0.43. What is the difference between the General Parity Index (GPI) of Lesotho in 1989 and the General Parity Index (GPI) of Malta in 2001?
Provide a short and direct response. 0.6. What is the difference between the General Parity Index (GPI) in Lesotho in 1989 and the General Parity Index (GPI) in St. Kitts and Nevis in 2001?
Ensure brevity in your answer.  0.43. What is the difference between the General Parity Index (GPI) in Malta in 1989 and the General Parity Index (GPI) in St. Kitts and Nevis in 2001?
Offer a terse response. -0.19. What is the difference between the General Parity Index (GPI) in Lower middle income in 1992 and the General Parity Index (GPI) in Lesotho in 1993?
Your answer should be very brief. -0.86. What is the difference between the General Parity Index (GPI) in Lower middle income in 1992 and the General Parity Index (GPI) in Malta in 1993?
Your answer should be compact. -0.2. What is the difference between the General Parity Index (GPI) of Lower middle income in 1992 and the General Parity Index (GPI) of St. Kitts and Nevis in 1993?
Your answer should be very brief. -0.34. What is the difference between the General Parity Index (GPI) in Lesotho in 1992 and the General Parity Index (GPI) in Malta in 1993?
Give a very brief answer. 0.66. What is the difference between the General Parity Index (GPI) of Lesotho in 1992 and the General Parity Index (GPI) of St. Kitts and Nevis in 1993?
Make the answer very short. 0.52. What is the difference between the General Parity Index (GPI) in Malta in 1992 and the General Parity Index (GPI) in St. Kitts and Nevis in 1993?
Your response must be concise. -0.15. What is the difference between the General Parity Index (GPI) in Lower middle income in 1992 and the General Parity Index (GPI) in Lesotho in 2000?
Provide a succinct answer. -0.65. What is the difference between the General Parity Index (GPI) in Lower middle income in 1992 and the General Parity Index (GPI) in Malta in 2000?
Make the answer very short. -0.26. What is the difference between the General Parity Index (GPI) of Lower middle income in 1992 and the General Parity Index (GPI) of St. Kitts and Nevis in 2000?
Your answer should be very brief. -0.39. What is the difference between the General Parity Index (GPI) of Lesotho in 1992 and the General Parity Index (GPI) of Malta in 2000?
Give a very brief answer. 0.6. What is the difference between the General Parity Index (GPI) in Lesotho in 1992 and the General Parity Index (GPI) in St. Kitts and Nevis in 2000?
Your answer should be compact. 0.48. What is the difference between the General Parity Index (GPI) of Malta in 1992 and the General Parity Index (GPI) of St. Kitts and Nevis in 2000?
Your response must be concise. -0.19. What is the difference between the General Parity Index (GPI) of Lower middle income in 1992 and the General Parity Index (GPI) of Lesotho in 2001?
Offer a terse response. -0.6. What is the difference between the General Parity Index (GPI) of Lower middle income in 1992 and the General Parity Index (GPI) of Malta in 2001?
Keep it short and to the point. -0.24. What is the difference between the General Parity Index (GPI) in Lower middle income in 1992 and the General Parity Index (GPI) in St. Kitts and Nevis in 2001?
Provide a short and direct response. -0.41. What is the difference between the General Parity Index (GPI) of Lesotho in 1992 and the General Parity Index (GPI) of Malta in 2001?
Your answer should be very brief. 0.63. What is the difference between the General Parity Index (GPI) in Lesotho in 1992 and the General Parity Index (GPI) in St. Kitts and Nevis in 2001?
Provide a short and direct response. 0.45. What is the difference between the General Parity Index (GPI) in Malta in 1992 and the General Parity Index (GPI) in St. Kitts and Nevis in 2001?
Keep it short and to the point. -0.21. What is the difference between the General Parity Index (GPI) of Lower middle income in 1993 and the General Parity Index (GPI) of Lesotho in 2000?
Your answer should be very brief. -0.64. What is the difference between the General Parity Index (GPI) in Lower middle income in 1993 and the General Parity Index (GPI) in Malta in 2000?
Give a very brief answer. -0.25. What is the difference between the General Parity Index (GPI) of Lower middle income in 1993 and the General Parity Index (GPI) of St. Kitts and Nevis in 2000?
Your answer should be compact. -0.38. What is the difference between the General Parity Index (GPI) of Lesotho in 1993 and the General Parity Index (GPI) of Malta in 2000?
Offer a very short reply. 0.6. What is the difference between the General Parity Index (GPI) in Lesotho in 1993 and the General Parity Index (GPI) in St. Kitts and Nevis in 2000?
Offer a terse response. 0.48. What is the difference between the General Parity Index (GPI) in Malta in 1993 and the General Parity Index (GPI) in St. Kitts and Nevis in 2000?
Your response must be concise. -0.19. What is the difference between the General Parity Index (GPI) in Lower middle income in 1993 and the General Parity Index (GPI) in Lesotho in 2001?
Your answer should be compact. -0.59. What is the difference between the General Parity Index (GPI) in Lower middle income in 1993 and the General Parity Index (GPI) in Malta in 2001?
Give a very brief answer. -0.23. What is the difference between the General Parity Index (GPI) of Lower middle income in 1993 and the General Parity Index (GPI) of St. Kitts and Nevis in 2001?
Make the answer very short. -0.4. What is the difference between the General Parity Index (GPI) in Lesotho in 1993 and the General Parity Index (GPI) in Malta in 2001?
Offer a terse response. 0.63. What is the difference between the General Parity Index (GPI) in Lesotho in 1993 and the General Parity Index (GPI) in St. Kitts and Nevis in 2001?
Provide a succinct answer. 0.45. What is the difference between the General Parity Index (GPI) of Malta in 1993 and the General Parity Index (GPI) of St. Kitts and Nevis in 2001?
Provide a succinct answer. -0.22. What is the difference between the General Parity Index (GPI) of Lower middle income in 2000 and the General Parity Index (GPI) of Lesotho in 2001?
Your response must be concise. -0.49. What is the difference between the General Parity Index (GPI) of Lower middle income in 2000 and the General Parity Index (GPI) of Malta in 2001?
Make the answer very short. -0.13. What is the difference between the General Parity Index (GPI) of Lower middle income in 2000 and the General Parity Index (GPI) of St. Kitts and Nevis in 2001?
Provide a succinct answer. -0.31. What is the difference between the General Parity Index (GPI) of Lesotho in 2000 and the General Parity Index (GPI) of Malta in 2001?
Give a very brief answer. 0.41. What is the difference between the General Parity Index (GPI) of Lesotho in 2000 and the General Parity Index (GPI) of St. Kitts and Nevis in 2001?
Your answer should be compact. 0.24. What is the difference between the General Parity Index (GPI) in Malta in 2000 and the General Parity Index (GPI) in St. Kitts and Nevis in 2001?
Offer a terse response. -0.15. What is the average General Parity Index (GPI) in Lower middle income per year?
Your answer should be very brief. 0.73. What is the average General Parity Index (GPI) of Lesotho per year?
Provide a succinct answer. 1.51. What is the average General Parity Index (GPI) of Malta per year?
Your response must be concise. 0.95. What is the average General Parity Index (GPI) of St. Kitts and Nevis per year?
Provide a succinct answer. 1.07. In the year 1986, what is the difference between the General Parity Index (GPI) in Lower middle income and General Parity Index (GPI) in Lesotho?
Offer a terse response. -0.86. In the year 1986, what is the difference between the General Parity Index (GPI) of Lower middle income and General Parity Index (GPI) of Malta?
Your answer should be very brief. -0.31. In the year 1986, what is the difference between the General Parity Index (GPI) in Lower middle income and General Parity Index (GPI) in St. Kitts and Nevis?
Your answer should be very brief. -0.32. In the year 1986, what is the difference between the General Parity Index (GPI) of Lesotho and General Parity Index (GPI) of Malta?
Your answer should be compact. 0.55. In the year 1986, what is the difference between the General Parity Index (GPI) in Lesotho and General Parity Index (GPI) in St. Kitts and Nevis?
Offer a terse response. 0.54. In the year 1986, what is the difference between the General Parity Index (GPI) in Malta and General Parity Index (GPI) in St. Kitts and Nevis?
Give a very brief answer. -0.01. In the year 1987, what is the difference between the General Parity Index (GPI) of Lower middle income and General Parity Index (GPI) of Lesotho?
Offer a terse response. -0.91. In the year 1987, what is the difference between the General Parity Index (GPI) in Lower middle income and General Parity Index (GPI) in Malta?
Offer a terse response. -0.3. In the year 1987, what is the difference between the General Parity Index (GPI) in Lower middle income and General Parity Index (GPI) in St. Kitts and Nevis?
Your response must be concise. -0.38. In the year 1987, what is the difference between the General Parity Index (GPI) of Lesotho and General Parity Index (GPI) of Malta?
Your answer should be compact. 0.61. In the year 1987, what is the difference between the General Parity Index (GPI) in Lesotho and General Parity Index (GPI) in St. Kitts and Nevis?
Keep it short and to the point. 0.53. In the year 1987, what is the difference between the General Parity Index (GPI) of Malta and General Parity Index (GPI) of St. Kitts and Nevis?
Ensure brevity in your answer.  -0.08. In the year 1988, what is the difference between the General Parity Index (GPI) of Lower middle income and General Parity Index (GPI) of Lesotho?
Offer a terse response. -0.92. In the year 1988, what is the difference between the General Parity Index (GPI) of Lower middle income and General Parity Index (GPI) of Malta?
Your answer should be very brief. -0.28. In the year 1988, what is the difference between the General Parity Index (GPI) of Lower middle income and General Parity Index (GPI) of St. Kitts and Nevis?
Your response must be concise. -0.41. In the year 1988, what is the difference between the General Parity Index (GPI) in Lesotho and General Parity Index (GPI) in Malta?
Offer a terse response. 0.63. In the year 1988, what is the difference between the General Parity Index (GPI) of Lesotho and General Parity Index (GPI) of St. Kitts and Nevis?
Ensure brevity in your answer.  0.5. In the year 1988, what is the difference between the General Parity Index (GPI) of Malta and General Parity Index (GPI) of St. Kitts and Nevis?
Offer a very short reply. -0.13. In the year 1989, what is the difference between the General Parity Index (GPI) in Lower middle income and General Parity Index (GPI) in Lesotho?
Your response must be concise. -0.86. In the year 1989, what is the difference between the General Parity Index (GPI) of Lower middle income and General Parity Index (GPI) of Malta?
Give a very brief answer. -0.24. In the year 1989, what is the difference between the General Parity Index (GPI) of Lower middle income and General Parity Index (GPI) of St. Kitts and Nevis?
Give a very brief answer. -0.39. In the year 1989, what is the difference between the General Parity Index (GPI) of Lesotho and General Parity Index (GPI) of Malta?
Ensure brevity in your answer.  0.62. In the year 1989, what is the difference between the General Parity Index (GPI) of Lesotho and General Parity Index (GPI) of St. Kitts and Nevis?
Keep it short and to the point. 0.47. In the year 1989, what is the difference between the General Parity Index (GPI) in Malta and General Parity Index (GPI) in St. Kitts and Nevis?
Keep it short and to the point. -0.15. In the year 1992, what is the difference between the General Parity Index (GPI) of Lower middle income and General Parity Index (GPI) of Lesotho?
Your response must be concise. -0.86. In the year 1992, what is the difference between the General Parity Index (GPI) in Lower middle income and General Parity Index (GPI) in Malta?
Provide a succinct answer. -0.2. In the year 1992, what is the difference between the General Parity Index (GPI) of Lower middle income and General Parity Index (GPI) of St. Kitts and Nevis?
Provide a short and direct response. -0.33. In the year 1992, what is the difference between the General Parity Index (GPI) in Lesotho and General Parity Index (GPI) in Malta?
Your answer should be very brief. 0.66. In the year 1992, what is the difference between the General Parity Index (GPI) of Lesotho and General Parity Index (GPI) of St. Kitts and Nevis?
Keep it short and to the point. 0.54. In the year 1992, what is the difference between the General Parity Index (GPI) in Malta and General Parity Index (GPI) in St. Kitts and Nevis?
Keep it short and to the point. -0.13. In the year 1993, what is the difference between the General Parity Index (GPI) in Lower middle income and General Parity Index (GPI) in Lesotho?
Your response must be concise. -0.85. In the year 1993, what is the difference between the General Parity Index (GPI) in Lower middle income and General Parity Index (GPI) in Malta?
Provide a succinct answer. -0.19. In the year 1993, what is the difference between the General Parity Index (GPI) of Lower middle income and General Parity Index (GPI) of St. Kitts and Nevis?
Keep it short and to the point. -0.34. In the year 1993, what is the difference between the General Parity Index (GPI) of Lesotho and General Parity Index (GPI) of Malta?
Offer a very short reply. 0.67. In the year 1993, what is the difference between the General Parity Index (GPI) in Lesotho and General Parity Index (GPI) in St. Kitts and Nevis?
Your response must be concise. 0.52. In the year 1993, what is the difference between the General Parity Index (GPI) in Malta and General Parity Index (GPI) in St. Kitts and Nevis?
Your response must be concise. -0.15. In the year 2000, what is the difference between the General Parity Index (GPI) of Lower middle income and General Parity Index (GPI) of Lesotho?
Your answer should be very brief. -0.55. In the year 2000, what is the difference between the General Parity Index (GPI) of Lower middle income and General Parity Index (GPI) of Malta?
Provide a short and direct response. -0.16. In the year 2000, what is the difference between the General Parity Index (GPI) of Lower middle income and General Parity Index (GPI) of St. Kitts and Nevis?
Provide a short and direct response. -0.28. In the year 2000, what is the difference between the General Parity Index (GPI) in Lesotho and General Parity Index (GPI) in Malta?
Provide a short and direct response. 0.39. In the year 2000, what is the difference between the General Parity Index (GPI) in Lesotho and General Parity Index (GPI) in St. Kitts and Nevis?
Offer a very short reply. 0.26. In the year 2000, what is the difference between the General Parity Index (GPI) of Malta and General Parity Index (GPI) of St. Kitts and Nevis?
Make the answer very short. -0.12. In the year 2001, what is the difference between the General Parity Index (GPI) in Lower middle income and General Parity Index (GPI) in Lesotho?
Ensure brevity in your answer.  -0.49. In the year 2001, what is the difference between the General Parity Index (GPI) of Lower middle income and General Parity Index (GPI) of Malta?
Your answer should be compact. -0.12. In the year 2001, what is the difference between the General Parity Index (GPI) of Lower middle income and General Parity Index (GPI) of St. Kitts and Nevis?
Provide a succinct answer. -0.3. In the year 2001, what is the difference between the General Parity Index (GPI) in Lesotho and General Parity Index (GPI) in Malta?
Offer a terse response. 0.36. In the year 2001, what is the difference between the General Parity Index (GPI) of Lesotho and General Parity Index (GPI) of St. Kitts and Nevis?
Your response must be concise. 0.19. In the year 2001, what is the difference between the General Parity Index (GPI) of Malta and General Parity Index (GPI) of St. Kitts and Nevis?
Keep it short and to the point. -0.18. What is the ratio of the General Parity Index (GPI) in Lower middle income in 1986 to that in 1987?
Offer a very short reply. 0.99. What is the ratio of the General Parity Index (GPI) of Lesotho in 1986 to that in 1987?
Ensure brevity in your answer.  0.96. What is the ratio of the General Parity Index (GPI) of Malta in 1986 to that in 1987?
Give a very brief answer. 1. What is the ratio of the General Parity Index (GPI) in St. Kitts and Nevis in 1986 to that in 1987?
Keep it short and to the point. 0.94. What is the ratio of the General Parity Index (GPI) in Lower middle income in 1986 to that in 1988?
Give a very brief answer. 0.97. What is the ratio of the General Parity Index (GPI) in Lesotho in 1986 to that in 1988?
Offer a terse response. 0.96. What is the ratio of the General Parity Index (GPI) in Malta in 1986 to that in 1988?
Your answer should be very brief. 1.01. What is the ratio of the General Parity Index (GPI) in St. Kitts and Nevis in 1986 to that in 1988?
Give a very brief answer. 0.9. What is the ratio of the General Parity Index (GPI) in Lower middle income in 1986 to that in 1989?
Your answer should be compact. 0.96. What is the ratio of the General Parity Index (GPI) of Lesotho in 1986 to that in 1989?
Give a very brief answer. 0.99. What is the ratio of the General Parity Index (GPI) in Malta in 1986 to that in 1989?
Ensure brevity in your answer.  1.04. What is the ratio of the General Parity Index (GPI) of Lower middle income in 1986 to that in 1992?
Your answer should be compact. 0.93. What is the ratio of the General Parity Index (GPI) in Malta in 1986 to that in 1992?
Your answer should be very brief. 1.07. What is the ratio of the General Parity Index (GPI) in St. Kitts and Nevis in 1986 to that in 1992?
Ensure brevity in your answer.  0.95. What is the ratio of the General Parity Index (GPI) in Lower middle income in 1986 to that in 1993?
Your response must be concise. 0.92. What is the ratio of the General Parity Index (GPI) in Lesotho in 1986 to that in 1993?
Keep it short and to the point. 0.97. What is the ratio of the General Parity Index (GPI) in Malta in 1986 to that in 1993?
Make the answer very short. 1.07. What is the ratio of the General Parity Index (GPI) in St. Kitts and Nevis in 1986 to that in 1993?
Provide a short and direct response. 0.93. What is the ratio of the General Parity Index (GPI) in Lower middle income in 1986 to that in 2000?
Offer a very short reply. 0.81. What is the ratio of the General Parity Index (GPI) of Lesotho in 1986 to that in 2000?
Offer a very short reply. 1.12. What is the ratio of the General Parity Index (GPI) of St. Kitts and Nevis in 1986 to that in 2000?
Your answer should be compact. 0.9. What is the ratio of the General Parity Index (GPI) in Lower middle income in 1986 to that in 2001?
Provide a short and direct response. 0.81. What is the ratio of the General Parity Index (GPI) in Lesotho in 1986 to that in 2001?
Your answer should be compact. 1.16. What is the ratio of the General Parity Index (GPI) in Malta in 1986 to that in 2001?
Offer a terse response. 1.02. What is the ratio of the General Parity Index (GPI) in St. Kitts and Nevis in 1986 to that in 2001?
Provide a succinct answer. 0.88. What is the ratio of the General Parity Index (GPI) in St. Kitts and Nevis in 1987 to that in 1988?
Offer a terse response. 0.96. What is the ratio of the General Parity Index (GPI) in Lower middle income in 1987 to that in 1989?
Give a very brief answer. 0.98. What is the ratio of the General Parity Index (GPI) of Lesotho in 1987 to that in 1989?
Provide a succinct answer. 1.02. What is the ratio of the General Parity Index (GPI) of Malta in 1987 to that in 1989?
Make the answer very short. 1.04. What is the ratio of the General Parity Index (GPI) of St. Kitts and Nevis in 1987 to that in 1989?
Provide a short and direct response. 0.98. What is the ratio of the General Parity Index (GPI) of Lower middle income in 1987 to that in 1992?
Provide a short and direct response. 0.94. What is the ratio of the General Parity Index (GPI) in Lesotho in 1987 to that in 1992?
Provide a succinct answer. 1.01. What is the ratio of the General Parity Index (GPI) of Malta in 1987 to that in 1992?
Your answer should be very brief. 1.07. What is the ratio of the General Parity Index (GPI) in St. Kitts and Nevis in 1987 to that in 1992?
Make the answer very short. 1.01. What is the ratio of the General Parity Index (GPI) in Lower middle income in 1987 to that in 1993?
Keep it short and to the point. 0.94. What is the ratio of the General Parity Index (GPI) of Lesotho in 1987 to that in 1993?
Give a very brief answer. 1.01. What is the ratio of the General Parity Index (GPI) of Malta in 1987 to that in 1993?
Offer a terse response. 1.07. What is the ratio of the General Parity Index (GPI) of St. Kitts and Nevis in 1987 to that in 1993?
Your response must be concise. 1. What is the ratio of the General Parity Index (GPI) of Lower middle income in 1987 to that in 2000?
Provide a short and direct response. 0.82. What is the ratio of the General Parity Index (GPI) of Lesotho in 1987 to that in 2000?
Your response must be concise. 1.16. What is the ratio of the General Parity Index (GPI) of Malta in 1987 to that in 2000?
Your answer should be compact. 1. What is the ratio of the General Parity Index (GPI) of St. Kitts and Nevis in 1987 to that in 2000?
Provide a short and direct response. 0.96. What is the ratio of the General Parity Index (GPI) of Lower middle income in 1987 to that in 2001?
Make the answer very short. 0.82. What is the ratio of the General Parity Index (GPI) in Lesotho in 1987 to that in 2001?
Offer a very short reply. 1.21. What is the ratio of the General Parity Index (GPI) of Malta in 1987 to that in 2001?
Provide a succinct answer. 1.02. What is the ratio of the General Parity Index (GPI) of St. Kitts and Nevis in 1987 to that in 2001?
Your response must be concise. 0.94. What is the ratio of the General Parity Index (GPI) in Lower middle income in 1988 to that in 1989?
Make the answer very short. 0.99. What is the ratio of the General Parity Index (GPI) in Lesotho in 1988 to that in 1989?
Give a very brief answer. 1.03. What is the ratio of the General Parity Index (GPI) in Malta in 1988 to that in 1989?
Ensure brevity in your answer.  1.03. What is the ratio of the General Parity Index (GPI) in St. Kitts and Nevis in 1988 to that in 1989?
Your answer should be very brief. 1.01. What is the ratio of the General Parity Index (GPI) of Lower middle income in 1988 to that in 1992?
Your response must be concise. 0.96. What is the ratio of the General Parity Index (GPI) in Lesotho in 1988 to that in 1992?
Keep it short and to the point. 1.01. What is the ratio of the General Parity Index (GPI) of Malta in 1988 to that in 1992?
Your answer should be very brief. 1.06. What is the ratio of the General Parity Index (GPI) in St. Kitts and Nevis in 1988 to that in 1992?
Give a very brief answer. 1.05. What is the ratio of the General Parity Index (GPI) in Lower middle income in 1988 to that in 1993?
Your answer should be compact. 0.95. What is the ratio of the General Parity Index (GPI) in Lesotho in 1988 to that in 1993?
Your response must be concise. 1.01. What is the ratio of the General Parity Index (GPI) of Malta in 1988 to that in 1993?
Offer a very short reply. 1.06. What is the ratio of the General Parity Index (GPI) of St. Kitts and Nevis in 1988 to that in 1993?
Provide a short and direct response. 1.03. What is the ratio of the General Parity Index (GPI) of Lower middle income in 1988 to that in 2000?
Your response must be concise. 0.83. What is the ratio of the General Parity Index (GPI) of Lesotho in 1988 to that in 2000?
Offer a terse response. 1.17. What is the ratio of the General Parity Index (GPI) of Lower middle income in 1988 to that in 2001?
Offer a very short reply. 0.83. What is the ratio of the General Parity Index (GPI) of Lesotho in 1988 to that in 2001?
Keep it short and to the point. 1.22. What is the ratio of the General Parity Index (GPI) of Malta in 1988 to that in 2001?
Make the answer very short. 1.01. What is the ratio of the General Parity Index (GPI) of St. Kitts and Nevis in 1988 to that in 2001?
Offer a terse response. 0.97. What is the ratio of the General Parity Index (GPI) of Lower middle income in 1989 to that in 1992?
Offer a very short reply. 0.97. What is the ratio of the General Parity Index (GPI) of Lesotho in 1989 to that in 1992?
Keep it short and to the point. 0.98. What is the ratio of the General Parity Index (GPI) in Malta in 1989 to that in 1992?
Offer a terse response. 1.02. What is the ratio of the General Parity Index (GPI) in St. Kitts and Nevis in 1989 to that in 1992?
Make the answer very short. 1.04. What is the ratio of the General Parity Index (GPI) in Lower middle income in 1989 to that in 1993?
Your answer should be compact. 0.96. What is the ratio of the General Parity Index (GPI) of Lesotho in 1989 to that in 1993?
Offer a very short reply. 0.98. What is the ratio of the General Parity Index (GPI) of Malta in 1989 to that in 1993?
Provide a short and direct response. 1.02. What is the ratio of the General Parity Index (GPI) of St. Kitts and Nevis in 1989 to that in 1993?
Ensure brevity in your answer.  1.02. What is the ratio of the General Parity Index (GPI) in Lower middle income in 1989 to that in 2000?
Ensure brevity in your answer.  0.85. What is the ratio of the General Parity Index (GPI) of Lesotho in 1989 to that in 2000?
Provide a short and direct response. 1.14. What is the ratio of the General Parity Index (GPI) in Malta in 1989 to that in 2000?
Offer a terse response. 0.96. What is the ratio of the General Parity Index (GPI) in St. Kitts and Nevis in 1989 to that in 2000?
Keep it short and to the point. 0.98. What is the ratio of the General Parity Index (GPI) of Lower middle income in 1989 to that in 2001?
Offer a very short reply. 0.84. What is the ratio of the General Parity Index (GPI) in Lesotho in 1989 to that in 2001?
Offer a very short reply. 1.18. What is the ratio of the General Parity Index (GPI) in Malta in 1989 to that in 2001?
Offer a very short reply. 0.98. What is the ratio of the General Parity Index (GPI) of St. Kitts and Nevis in 1989 to that in 2001?
Make the answer very short. 0.96. What is the ratio of the General Parity Index (GPI) in Lower middle income in 1992 to that in 1993?
Make the answer very short. 0.99. What is the ratio of the General Parity Index (GPI) in St. Kitts and Nevis in 1992 to that in 1993?
Offer a terse response. 0.98. What is the ratio of the General Parity Index (GPI) in Lower middle income in 1992 to that in 2000?
Ensure brevity in your answer.  0.87. What is the ratio of the General Parity Index (GPI) in Lesotho in 1992 to that in 2000?
Your response must be concise. 1.16. What is the ratio of the General Parity Index (GPI) of Malta in 1992 to that in 2000?
Keep it short and to the point. 0.93. What is the ratio of the General Parity Index (GPI) of St. Kitts and Nevis in 1992 to that in 2000?
Your answer should be very brief. 0.95. What is the ratio of the General Parity Index (GPI) in Lower middle income in 1992 to that in 2001?
Offer a very short reply. 0.87. What is the ratio of the General Parity Index (GPI) of Lesotho in 1992 to that in 2001?
Ensure brevity in your answer.  1.2. What is the ratio of the General Parity Index (GPI) in Malta in 1992 to that in 2001?
Your response must be concise. 0.96. What is the ratio of the General Parity Index (GPI) of St. Kitts and Nevis in 1992 to that in 2001?
Offer a terse response. 0.92. What is the ratio of the General Parity Index (GPI) of Lower middle income in 1993 to that in 2000?
Your response must be concise. 0.88. What is the ratio of the General Parity Index (GPI) in Lesotho in 1993 to that in 2000?
Your answer should be very brief. 1.16. What is the ratio of the General Parity Index (GPI) in Malta in 1993 to that in 2000?
Offer a very short reply. 0.93. What is the ratio of the General Parity Index (GPI) in St. Kitts and Nevis in 1993 to that in 2000?
Your response must be concise. 0.96. What is the ratio of the General Parity Index (GPI) in Lower middle income in 1993 to that in 2001?
Provide a succinct answer. 0.87. What is the ratio of the General Parity Index (GPI) of Lesotho in 1993 to that in 2001?
Your response must be concise. 1.2. What is the ratio of the General Parity Index (GPI) in St. Kitts and Nevis in 1993 to that in 2001?
Your answer should be very brief. 0.94. What is the ratio of the General Parity Index (GPI) in Lesotho in 2000 to that in 2001?
Your answer should be very brief. 1.04. What is the ratio of the General Parity Index (GPI) in Malta in 2000 to that in 2001?
Make the answer very short. 1.03. What is the ratio of the General Parity Index (GPI) in St. Kitts and Nevis in 2000 to that in 2001?
Give a very brief answer. 0.98. What is the difference between the highest and the second highest General Parity Index (GPI) in Lower middle income?
Ensure brevity in your answer.  0.01. What is the difference between the highest and the second highest General Parity Index (GPI) in Lesotho?
Provide a short and direct response. 0.01. What is the difference between the highest and the second highest General Parity Index (GPI) in Malta?
Keep it short and to the point. 0. What is the difference between the highest and the second highest General Parity Index (GPI) of St. Kitts and Nevis?
Your response must be concise. 0.03. What is the difference between the highest and the lowest General Parity Index (GPI) in Lower middle income?
Ensure brevity in your answer.  0.16. What is the difference between the highest and the lowest General Parity Index (GPI) of Lesotho?
Provide a succinct answer. 0.29. What is the difference between the highest and the lowest General Parity Index (GPI) of Malta?
Make the answer very short. 0.06. What is the difference between the highest and the lowest General Parity Index (GPI) in St. Kitts and Nevis?
Your answer should be compact. 0.14. 